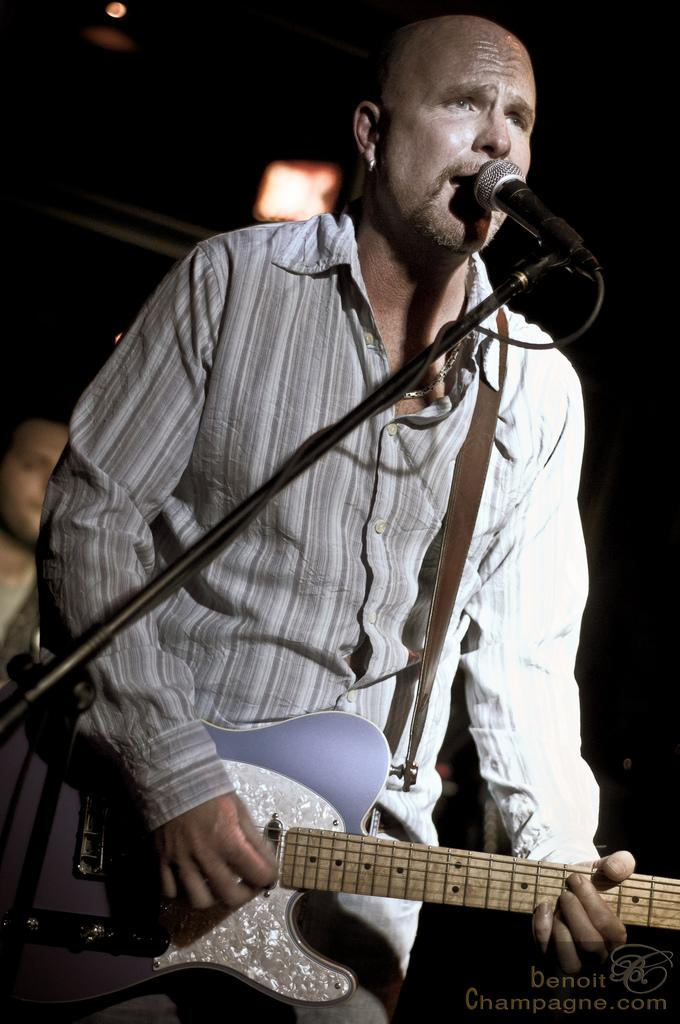What is the man in the image doing? The man is playing a guitar and singing into a microphone. What instrument is the man playing in the image? The man is playing a guitar. Can you describe the other person in the image? There is another person in the background of the image, but no specific details are provided. What is the birth date of the guitar in the image? The guitar in the image is an inanimate object and does not have a birth date. 